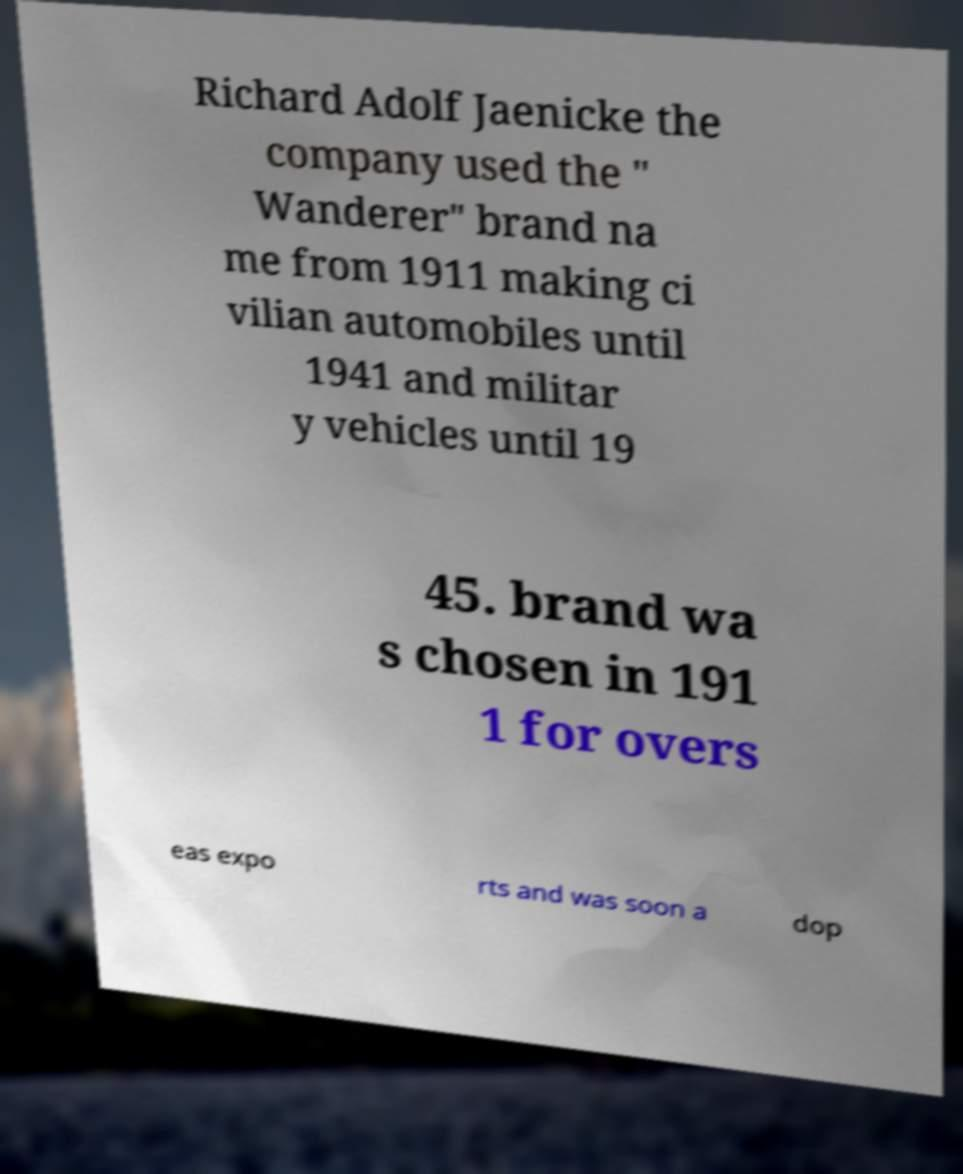Could you assist in decoding the text presented in this image and type it out clearly? Richard Adolf Jaenicke the company used the " Wanderer" brand na me from 1911 making ci vilian automobiles until 1941 and militar y vehicles until 19 45. brand wa s chosen in 191 1 for overs eas expo rts and was soon a dop 